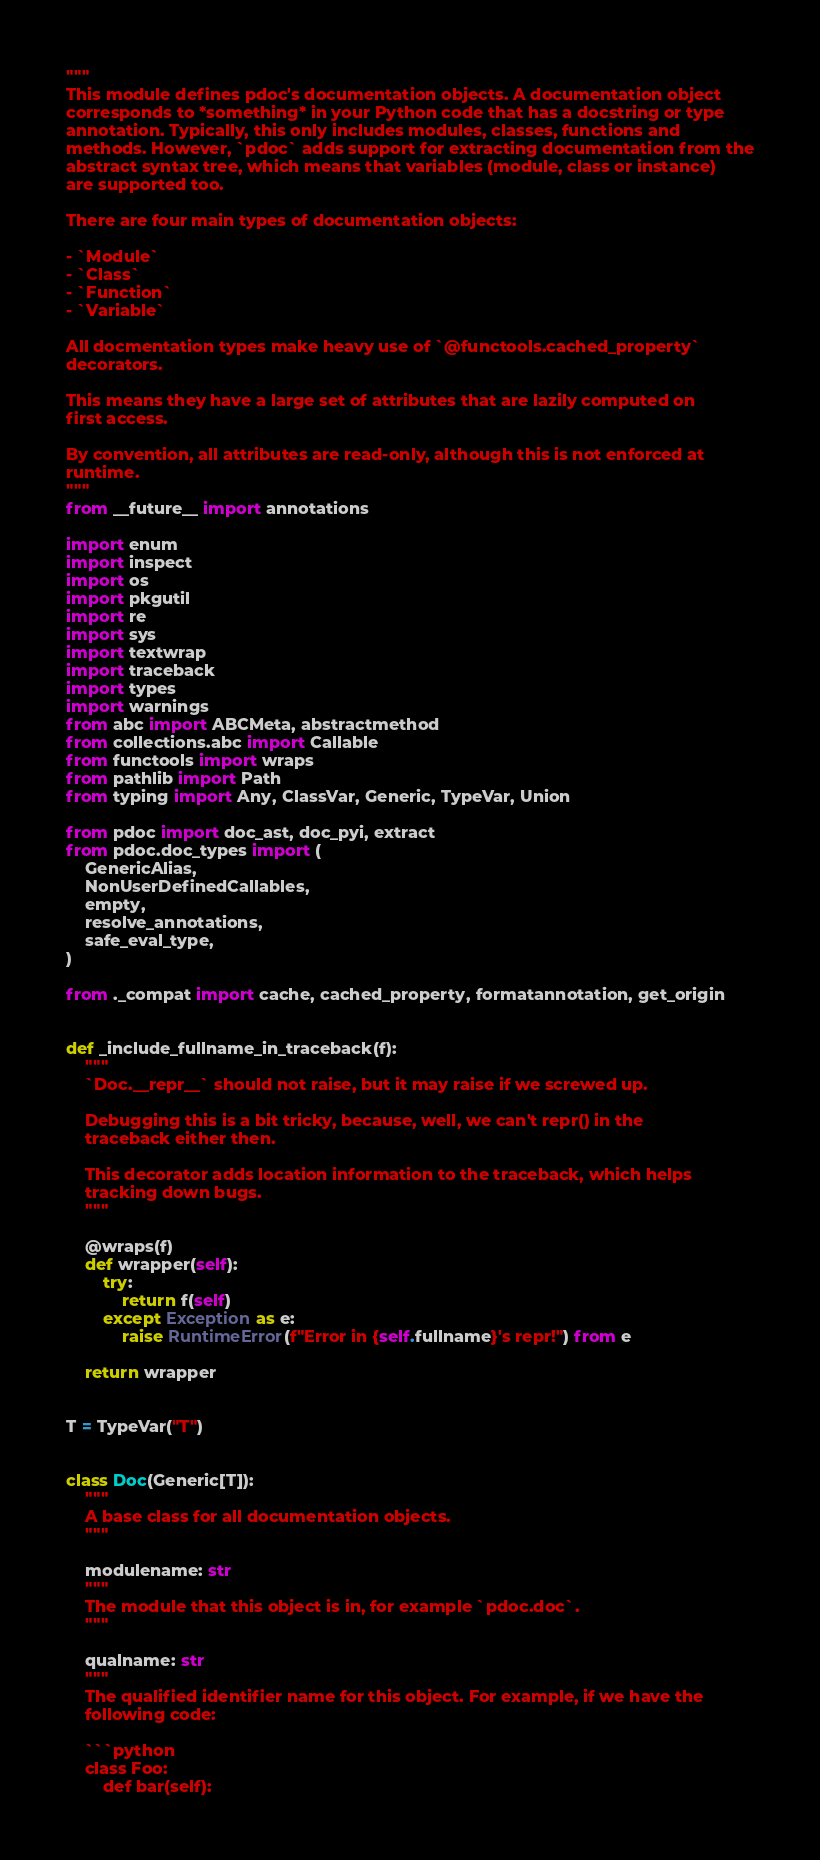<code> <loc_0><loc_0><loc_500><loc_500><_Python_>"""
This module defines pdoc's documentation objects. A documentation object
corresponds to *something* in your Python code that has a docstring or type
annotation. Typically, this only includes modules, classes, functions and
methods. However, `pdoc` adds support for extracting documentation from the
abstract syntax tree, which means that variables (module, class or instance)
are supported too.

There are four main types of documentation objects:

- `Module`
- `Class`
- `Function`
- `Variable`

All docmentation types make heavy use of `@functools.cached_property`
decorators.

This means they have a large set of attributes that are lazily computed on
first access.

By convention, all attributes are read-only, although this is not enforced at
runtime.
"""
from __future__ import annotations

import enum
import inspect
import os
import pkgutil
import re
import sys
import textwrap
import traceback
import types
import warnings
from abc import ABCMeta, abstractmethod
from collections.abc import Callable
from functools import wraps
from pathlib import Path
from typing import Any, ClassVar, Generic, TypeVar, Union

from pdoc import doc_ast, doc_pyi, extract
from pdoc.doc_types import (
    GenericAlias,
    NonUserDefinedCallables,
    empty,
    resolve_annotations,
    safe_eval_type,
)

from ._compat import cache, cached_property, formatannotation, get_origin


def _include_fullname_in_traceback(f):
    """
    `Doc.__repr__` should not raise, but it may raise if we screwed up.

    Debugging this is a bit tricky, because, well, we can't repr() in the
    traceback either then.

    This decorator adds location information to the traceback, which helps
    tracking down bugs.
    """

    @wraps(f)
    def wrapper(self):
        try:
            return f(self)
        except Exception as e:
            raise RuntimeError(f"Error in {self.fullname}'s repr!") from e

    return wrapper


T = TypeVar("T")


class Doc(Generic[T]):
    """
    A base class for all documentation objects.
    """

    modulename: str
    """
    The module that this object is in, for example `pdoc.doc`.
    """

    qualname: str
    """
    The qualified identifier name for this object. For example, if we have the
    following code:

    ```python
    class Foo:
        def bar(self):</code> 